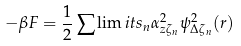Convert formula to latex. <formula><loc_0><loc_0><loc_500><loc_500>- \beta F = \frac { 1 } { 2 } \sum \lim i t s _ { n } \alpha _ { z \zeta _ { n } } ^ { 2 } \psi _ { \Delta \zeta _ { n } } ^ { 2 } ( r )</formula> 